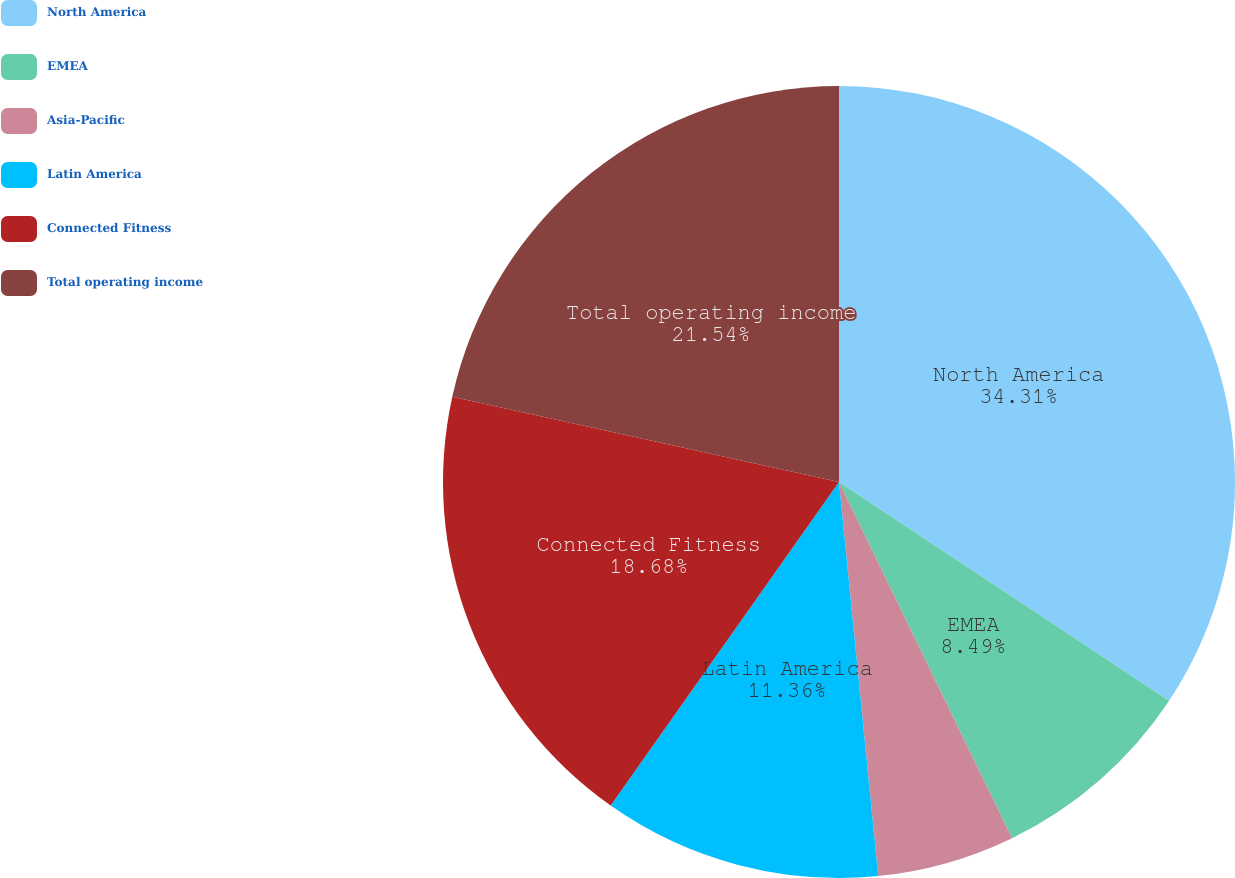Convert chart to OTSL. <chart><loc_0><loc_0><loc_500><loc_500><pie_chart><fcel>North America<fcel>EMEA<fcel>Asia-Pacific<fcel>Latin America<fcel>Connected Fitness<fcel>Total operating income<nl><fcel>34.32%<fcel>8.49%<fcel>5.62%<fcel>11.36%<fcel>18.68%<fcel>21.55%<nl></chart> 